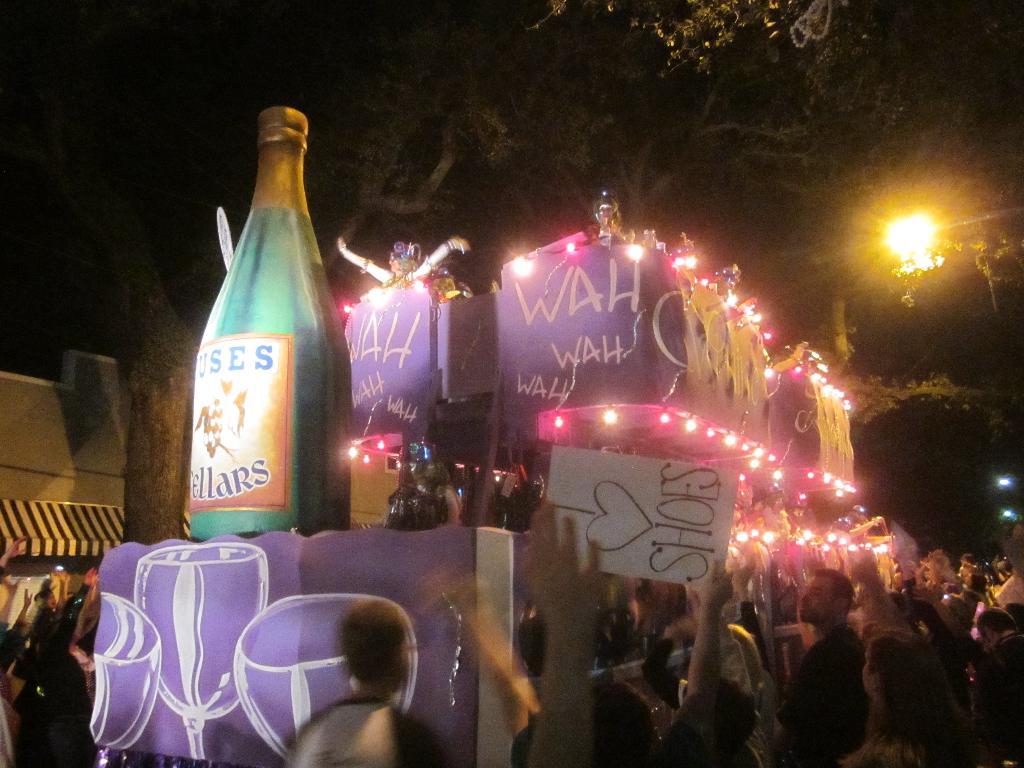What does the person holding the sign love?
Keep it short and to the point. Shoes. What is written on the purple sign that is completely visible?
Offer a very short reply. Wah wah wah. 